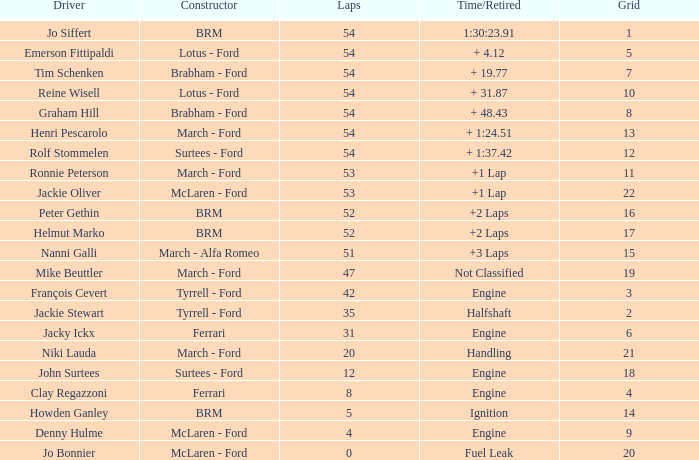What is the small grid with brm and more than 54 laps? None. I'm looking to parse the entire table for insights. Could you assist me with that? {'header': ['Driver', 'Constructor', 'Laps', 'Time/Retired', 'Grid'], 'rows': [['Jo Siffert', 'BRM', '54', '1:30:23.91', '1'], ['Emerson Fittipaldi', 'Lotus - Ford', '54', '+ 4.12', '5'], ['Tim Schenken', 'Brabham - Ford', '54', '+ 19.77', '7'], ['Reine Wisell', 'Lotus - Ford', '54', '+ 31.87', '10'], ['Graham Hill', 'Brabham - Ford', '54', '+ 48.43', '8'], ['Henri Pescarolo', 'March - Ford', '54', '+ 1:24.51', '13'], ['Rolf Stommelen', 'Surtees - Ford', '54', '+ 1:37.42', '12'], ['Ronnie Peterson', 'March - Ford', '53', '+1 Lap', '11'], ['Jackie Oliver', 'McLaren - Ford', '53', '+1 Lap', '22'], ['Peter Gethin', 'BRM', '52', '+2 Laps', '16'], ['Helmut Marko', 'BRM', '52', '+2 Laps', '17'], ['Nanni Galli', 'March - Alfa Romeo', '51', '+3 Laps', '15'], ['Mike Beuttler', 'March - Ford', '47', 'Not Classified', '19'], ['François Cevert', 'Tyrrell - Ford', '42', 'Engine', '3'], ['Jackie Stewart', 'Tyrrell - Ford', '35', 'Halfshaft', '2'], ['Jacky Ickx', 'Ferrari', '31', 'Engine', '6'], ['Niki Lauda', 'March - Ford', '20', 'Handling', '21'], ['John Surtees', 'Surtees - Ford', '12', 'Engine', '18'], ['Clay Regazzoni', 'Ferrari', '8', 'Engine', '4'], ['Howden Ganley', 'BRM', '5', 'Ignition', '14'], ['Denny Hulme', 'McLaren - Ford', '4', 'Engine', '9'], ['Jo Bonnier', 'McLaren - Ford', '0', 'Fuel Leak', '20']]} 